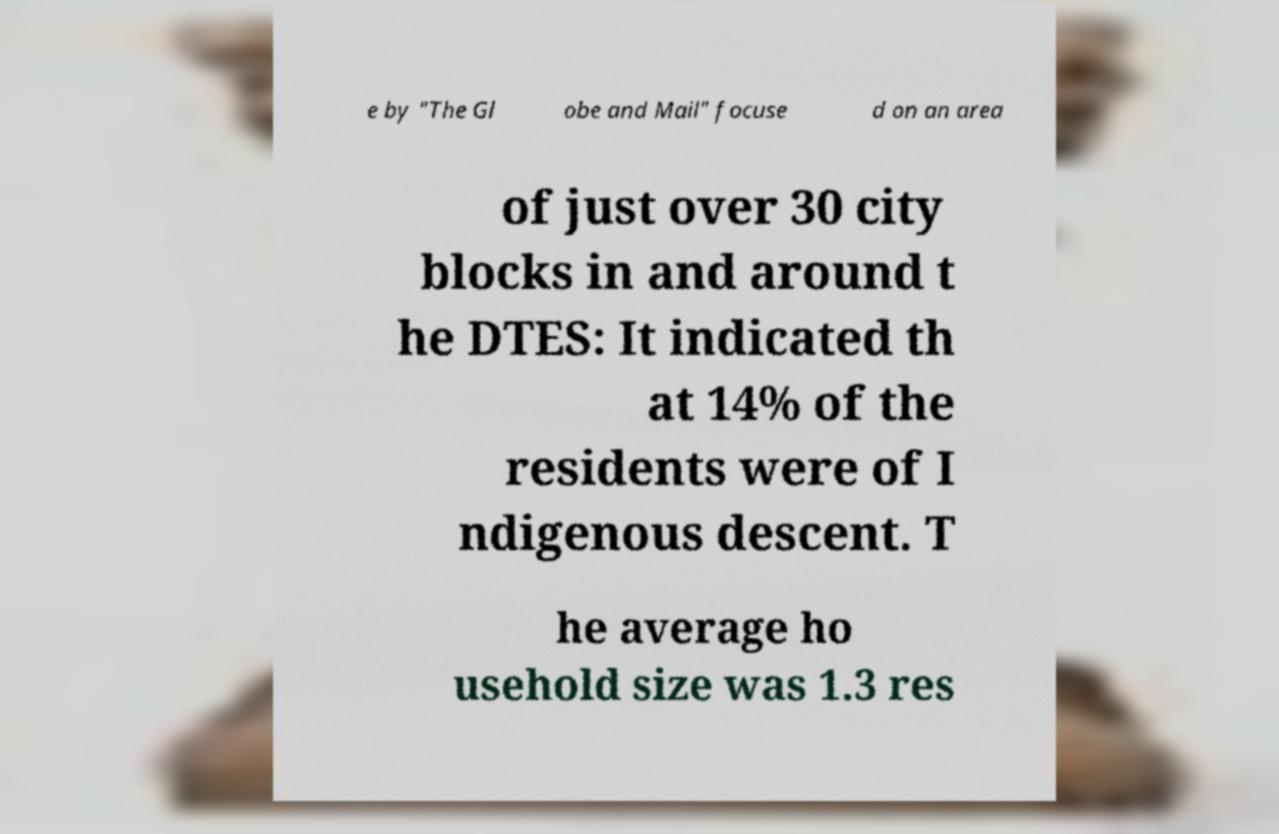Can you read and provide the text displayed in the image?This photo seems to have some interesting text. Can you extract and type it out for me? e by "The Gl obe and Mail" focuse d on an area of just over 30 city blocks in and around t he DTES: It indicated th at 14% of the residents were of I ndigenous descent. T he average ho usehold size was 1.3 res 